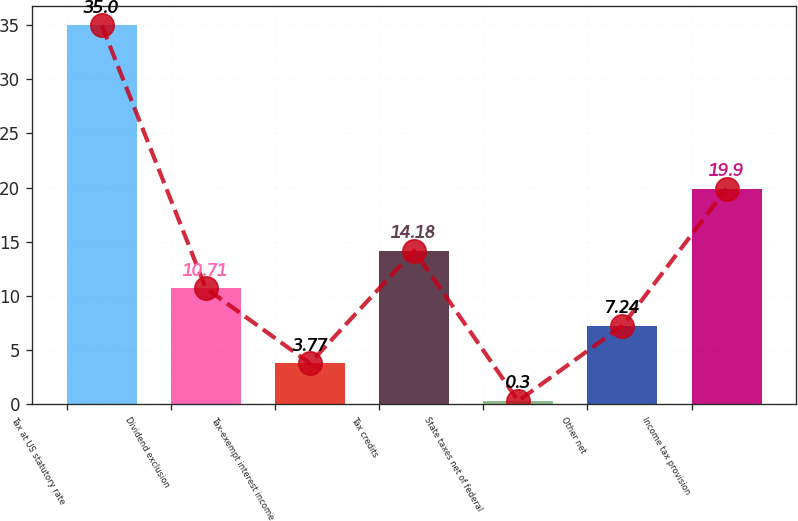<chart> <loc_0><loc_0><loc_500><loc_500><bar_chart><fcel>Tax at US statutory rate<fcel>Dividend exclusion<fcel>Tax-exempt interest income<fcel>Tax credits<fcel>State taxes net of federal<fcel>Other net<fcel>Income tax provision<nl><fcel>35<fcel>10.71<fcel>3.77<fcel>14.18<fcel>0.3<fcel>7.24<fcel>19.9<nl></chart> 